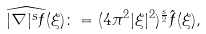<formula> <loc_0><loc_0><loc_500><loc_500>\widehat { | \nabla | ^ { s } f } ( \xi ) \colon = ( 4 \pi ^ { 2 } | \xi | ^ { 2 } ) ^ { \frac { s } { 2 } } \hat { f } ( \xi ) ,</formula> 